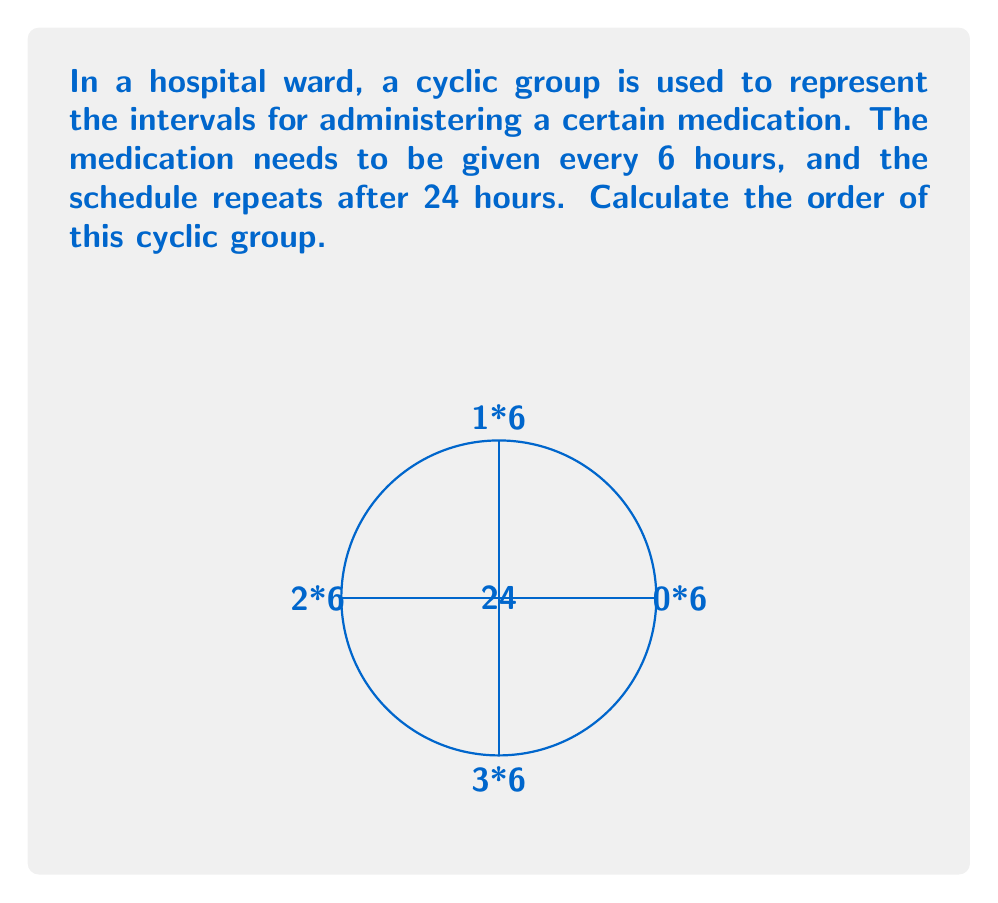Solve this math problem. To solve this problem, we need to understand the concept of cyclic groups and how they relate to the given medication schedule:

1) A cyclic group is a group that can be generated by a single element, called the generator.

2) In this case, the generator is the 6-hour interval, as every element in the group can be obtained by repeated application of this interval.

3) The order of a cyclic group is the number of unique elements in the group before it starts repeating.

4) To find the order, we need to determine how many unique elements we get before returning to the starting point (0 hours):

   $$ 0 \rightarrow 6 \rightarrow 12 \rightarrow 18 \rightarrow 24 (0) $$

5) We can see that after 4 applications of the 6-hour interval, we return to 0 (as 24 hours is equivalent to 0 in a 24-hour cycle).

6) Therefore, there are 4 unique elements in this cyclic group: {0, 6, 12, 18}.

7) The order of a cyclic group is equal to the number of its unique elements.

Thus, the order of this cyclic group is 4.
Answer: 4 